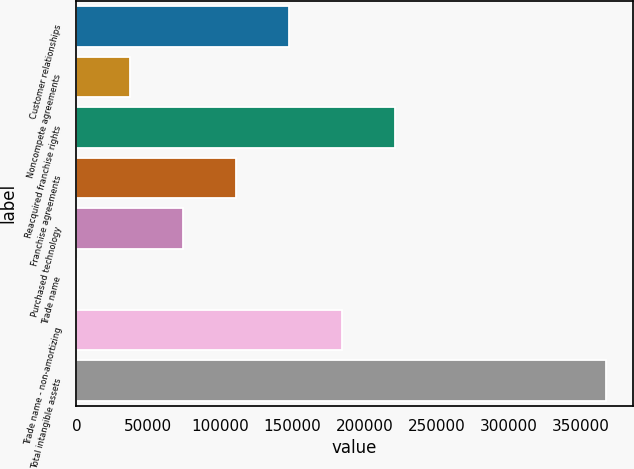Convert chart. <chart><loc_0><loc_0><loc_500><loc_500><bar_chart><fcel>Customer relationships<fcel>Noncompete agreements<fcel>Reacquired franchise rights<fcel>Franchise agreements<fcel>Purchased technology<fcel>Trade name<fcel>Trade name - non-amortizing<fcel>Total intangible assets<nl><fcel>147603<fcel>37444.4<fcel>221041<fcel>110883<fcel>74163.8<fcel>725<fcel>184322<fcel>367919<nl></chart> 